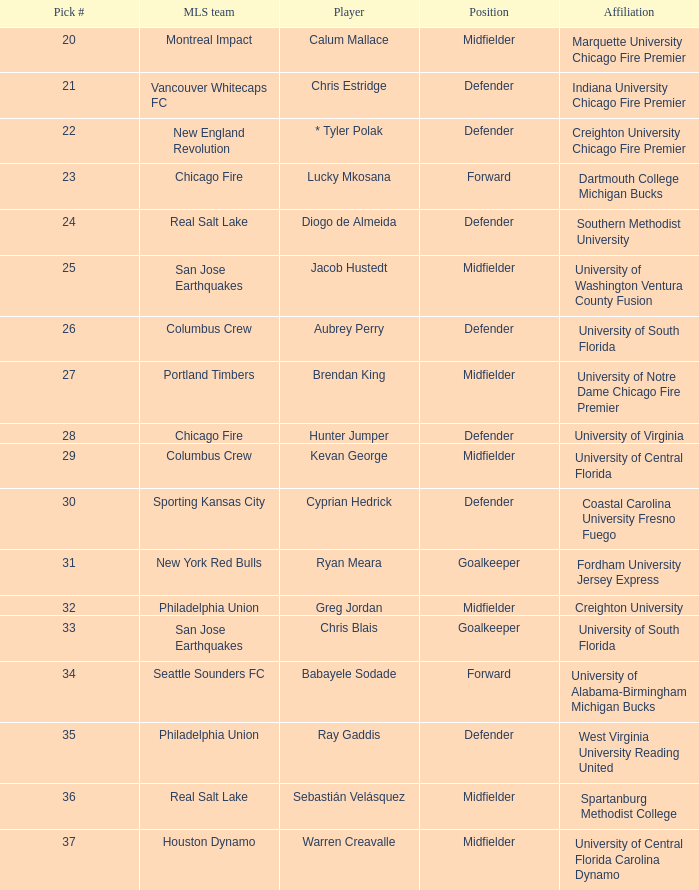At what position was kevan george picked? 29.0. 